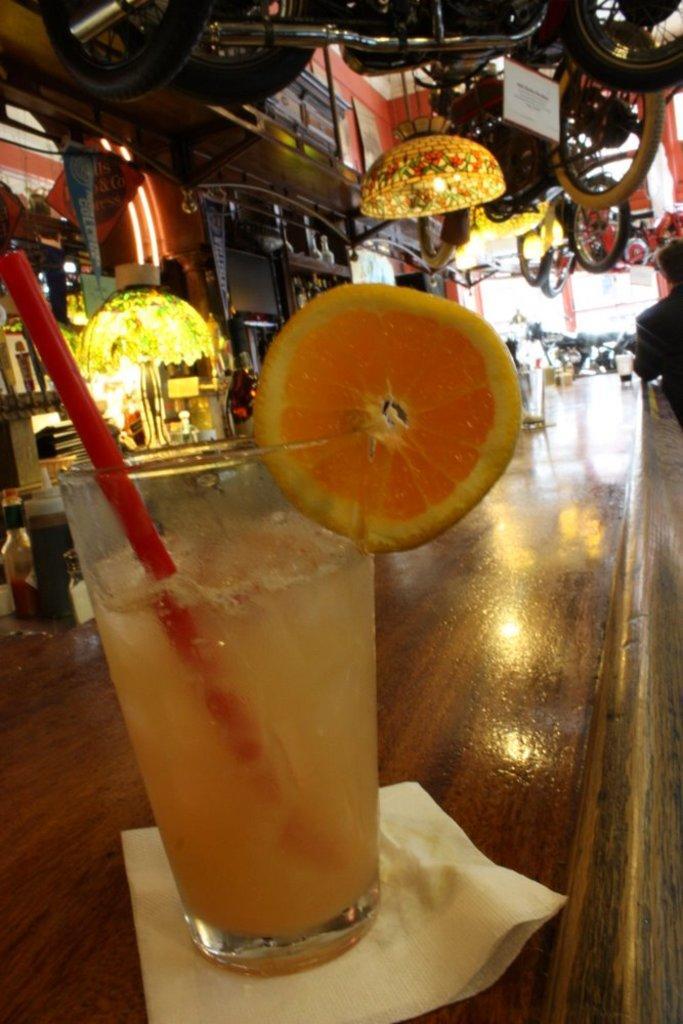How would you summarize this image in a sentence or two? The picture is taken in a restaurant. In the foreground of the picture there is a drink served in a glass placed on a table. In the background there are bicycles, bottles, glasses and chandelier. On the right there is a person. In the background towards left there are trees. 